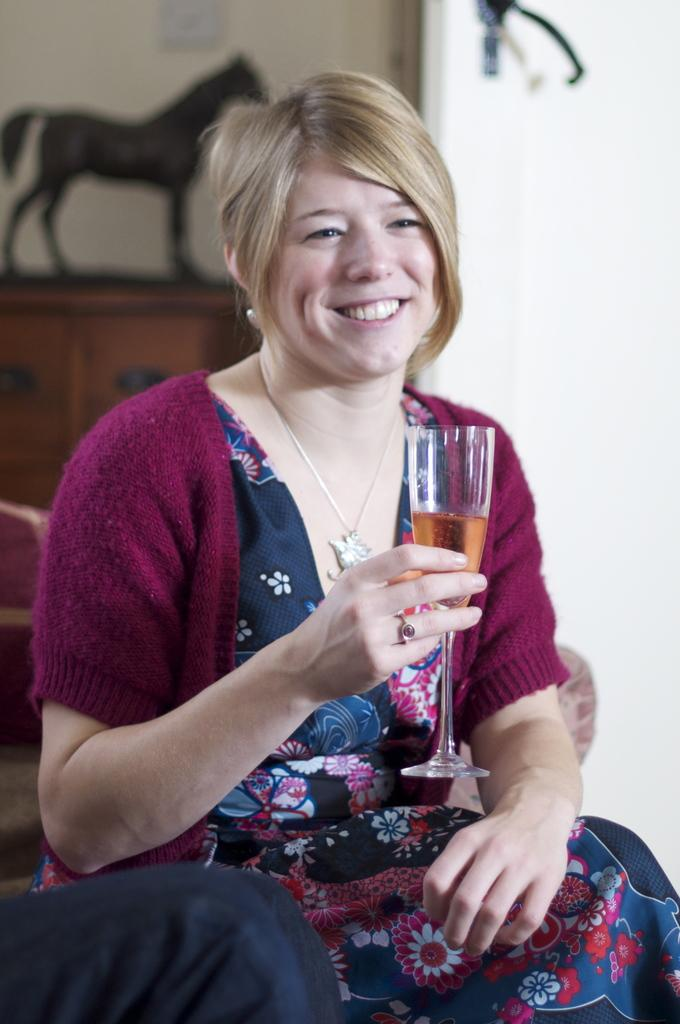Who is present in the image? There is a woman in the image. What is the woman doing in the image? The woman is sitting. What object is the woman holding in her hand? The woman is holding a glass in her hand. Can you see a kitten playing with the woman's hair in the image? No, there is no kitten present in the image. 